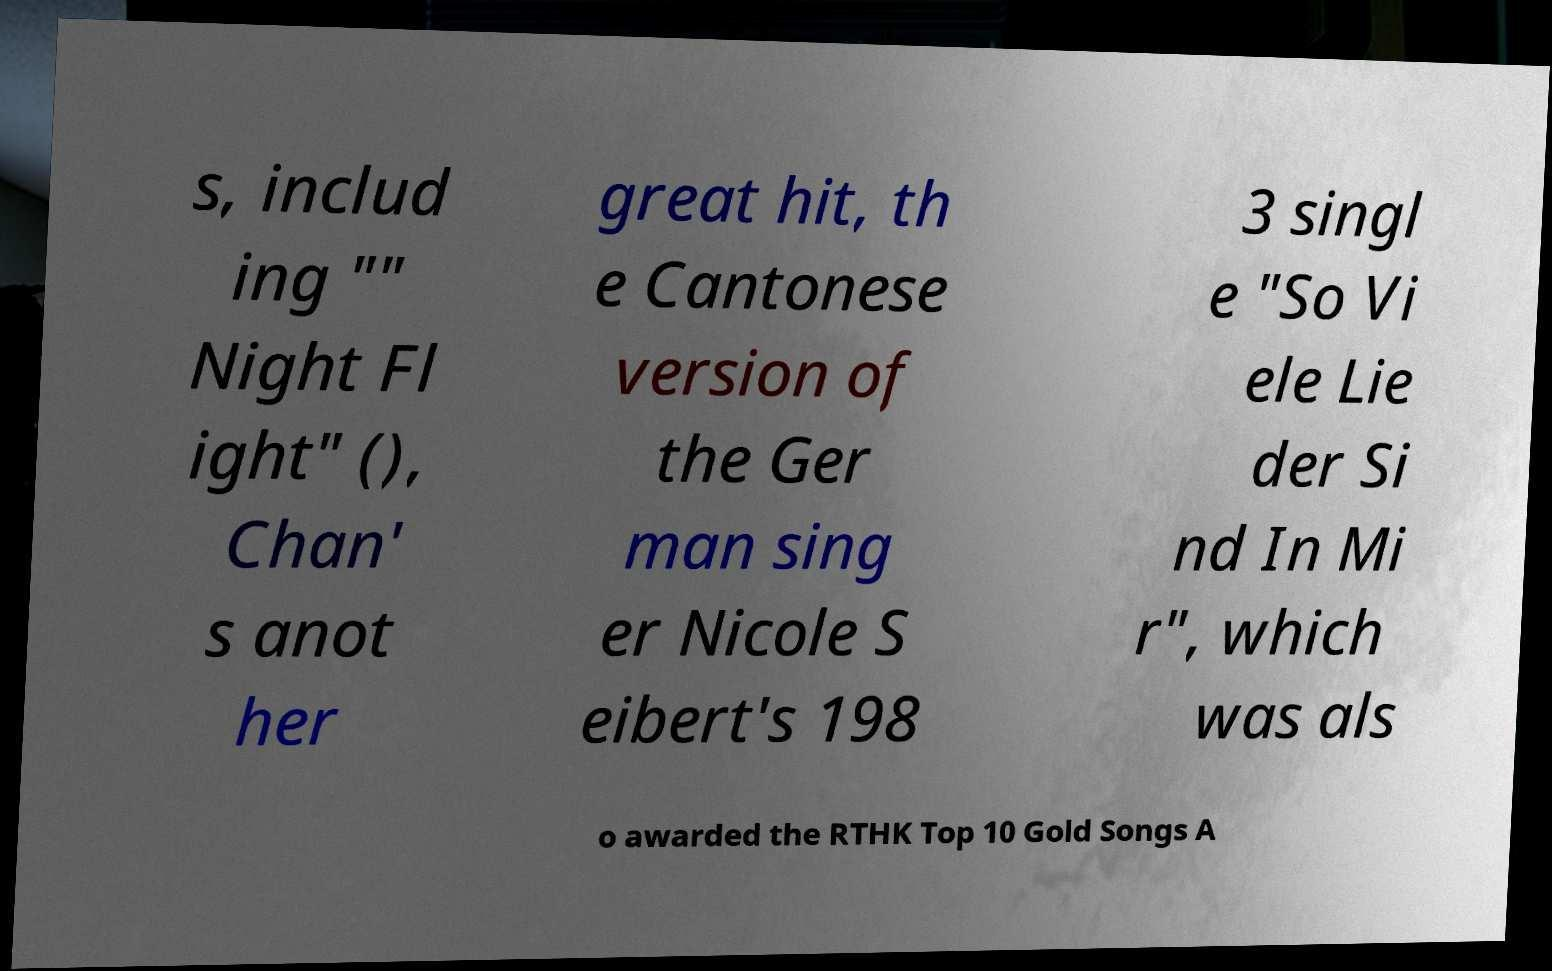I need the written content from this picture converted into text. Can you do that? s, includ ing "" Night Fl ight" (), Chan' s anot her great hit, th e Cantonese version of the Ger man sing er Nicole S eibert's 198 3 singl e "So Vi ele Lie der Si nd In Mi r", which was als o awarded the RTHK Top 10 Gold Songs A 